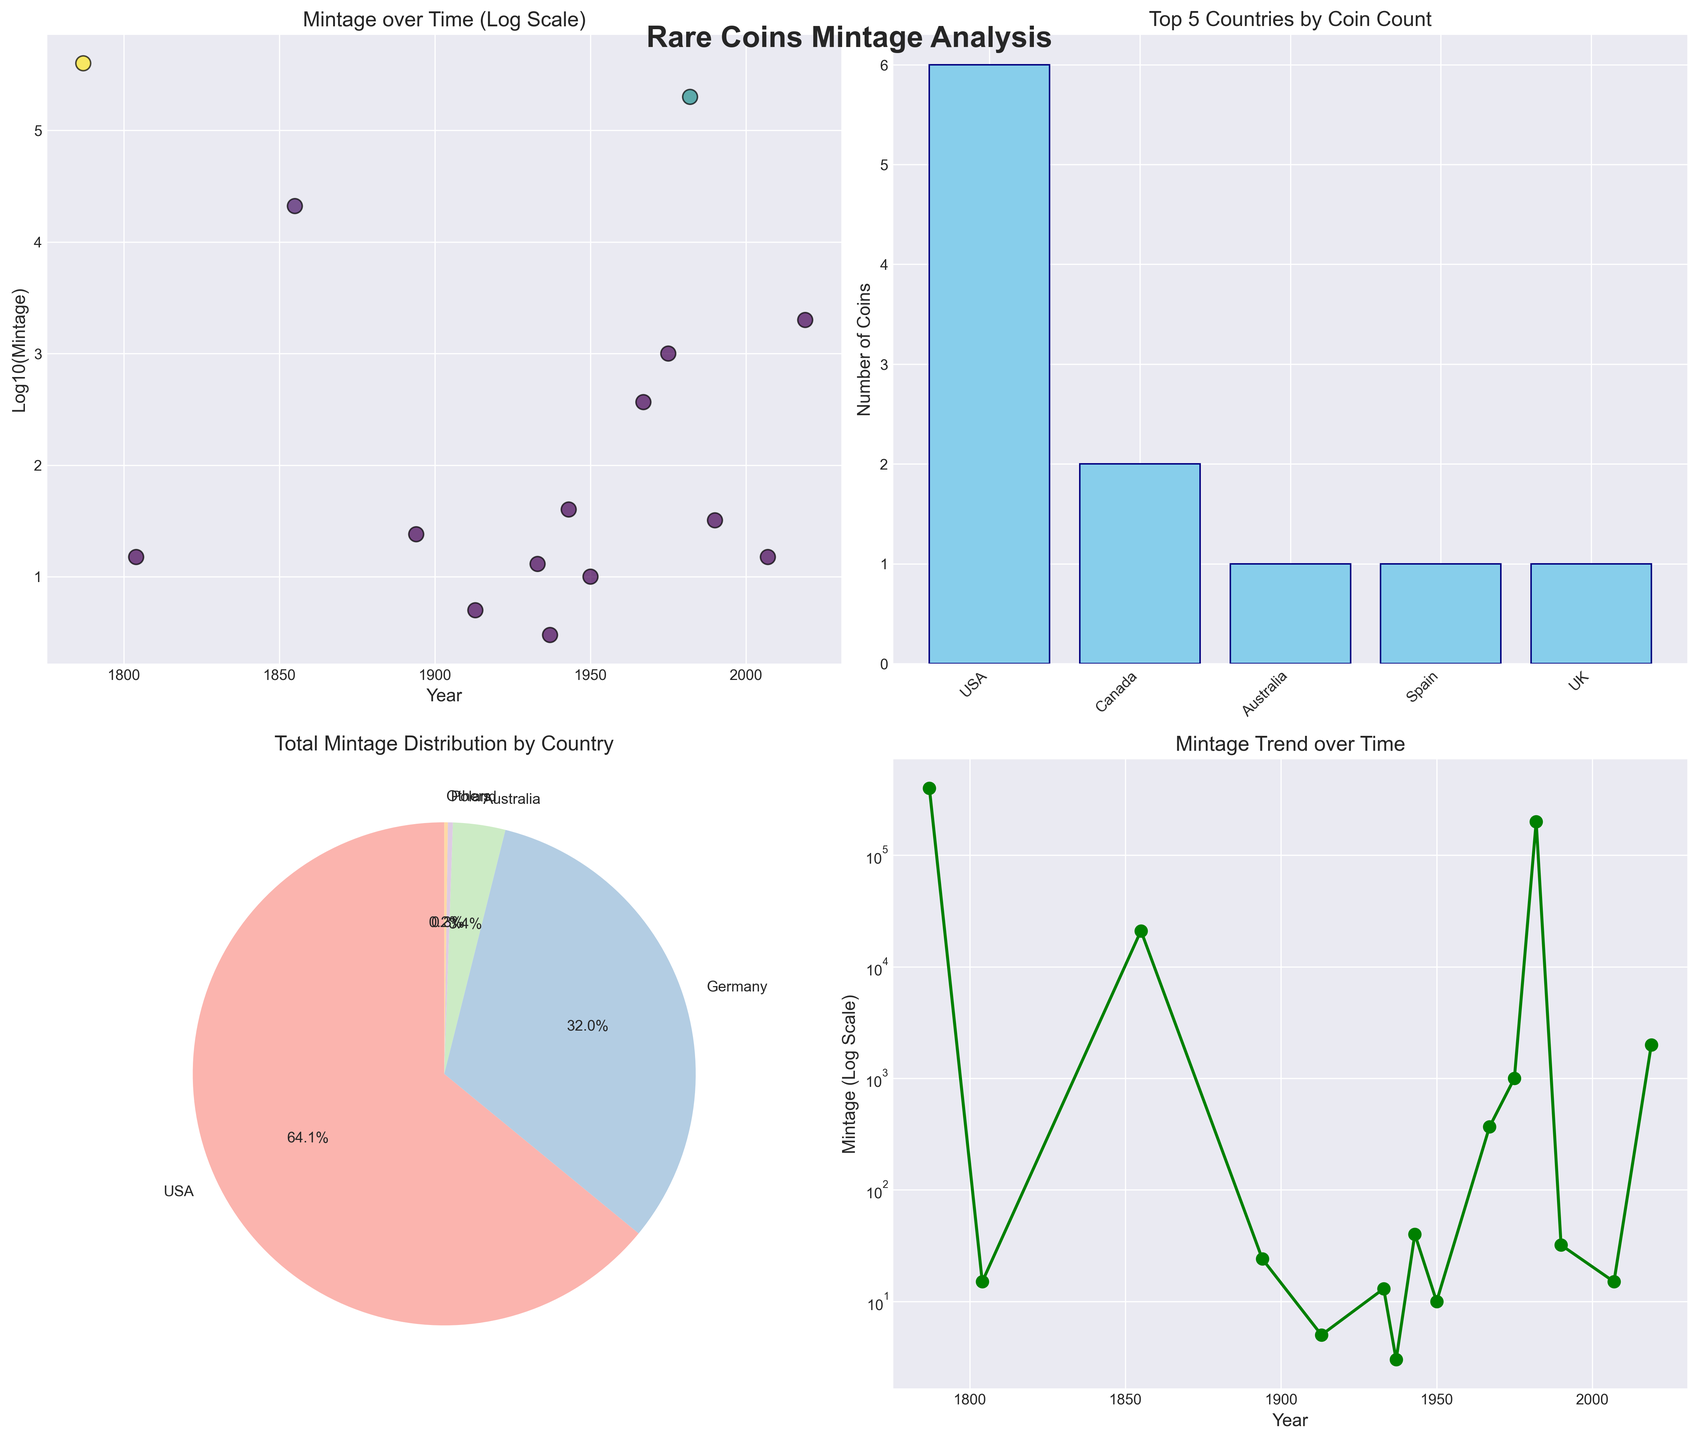What is the title of the entire figure? The title of the figure is located at the top center and reads "Rare Coins Mintage Analysis"
Answer: Rare Coins Mintage Analysis In the scatter plot, which year has the highest mintage count? In the scatter plot (top left), the year with the highest dot on the vertical axis of 'Log10(Mintage)' corresponds to the year 1787 with the coin "Fugio Cent" having a mintage of 400,000.
Answer: 1787 Which country is represented most frequently in the dataset according to the bar chart? The country with the tallest bar in the "Top 5 Countries by Coin Count" bar chart (top right) indicates the country with the most coins. The tallest bar belongs to the USA.
Answer: USA Based on the pie chart, which country has the largest share of total mintage? The pie chart (bottom left) shows different segments representing countries. The largest segment belongs to the USA, indicating it has the largest share of the total mintage.
Answer: USA How many countries are represented in the pie chart? Counting the labeled segments in the pie chart reveals there are 5 countries represented, including an "Others" category.
Answer: 5 Compare the mintage of the USA Liberty Head Nickel and the Canada Dot Cent. Which coin has a lower mintage? In both the scatter plot and the line plot, locate the data points representing '1913 USA Liberty Head Nickel' and '1937 Canada Dot Cent'. The Liberty Head Nickel has 5 mintage, while the Dot Cent has 3 mintage. Hence, the Dot Cent has a lower mintage.
Answer: Canada Dot Cent What is the approximate log scale value of the mintage for the year 1943 in the scatter plot? In the scatter plot, find the year 1943 and locate its corresponding dot. The vertical axis represents the log10(mintage). The mintage for 1943 is 40, and log10(40) is approximately 1.6.
Answer: 1.6 In the line plot, what is the general trend of mintage numbers from 1787 to 2019? Observing the line plot, you can see the mintage values fluctuate and vary considerably over different years. There is no consistent trend, but notable peaks and valleys can be observed at various points in time. The line is more volatile towards the earlier years and tends to stabilize with fewer extreme values towards the later years.
Answer: Volatile with fluctuations How does the mintage count for the year 1982 compare to the year 2007 in the line plot? In the line plot, locate the years 1982 and 2007. The year 1982 has a mintage count of 200,000, while 2007 has a mintage count of 15. The mintage for 1982 is significantly higher than for 2007.
Answer: 1982 > 2007 